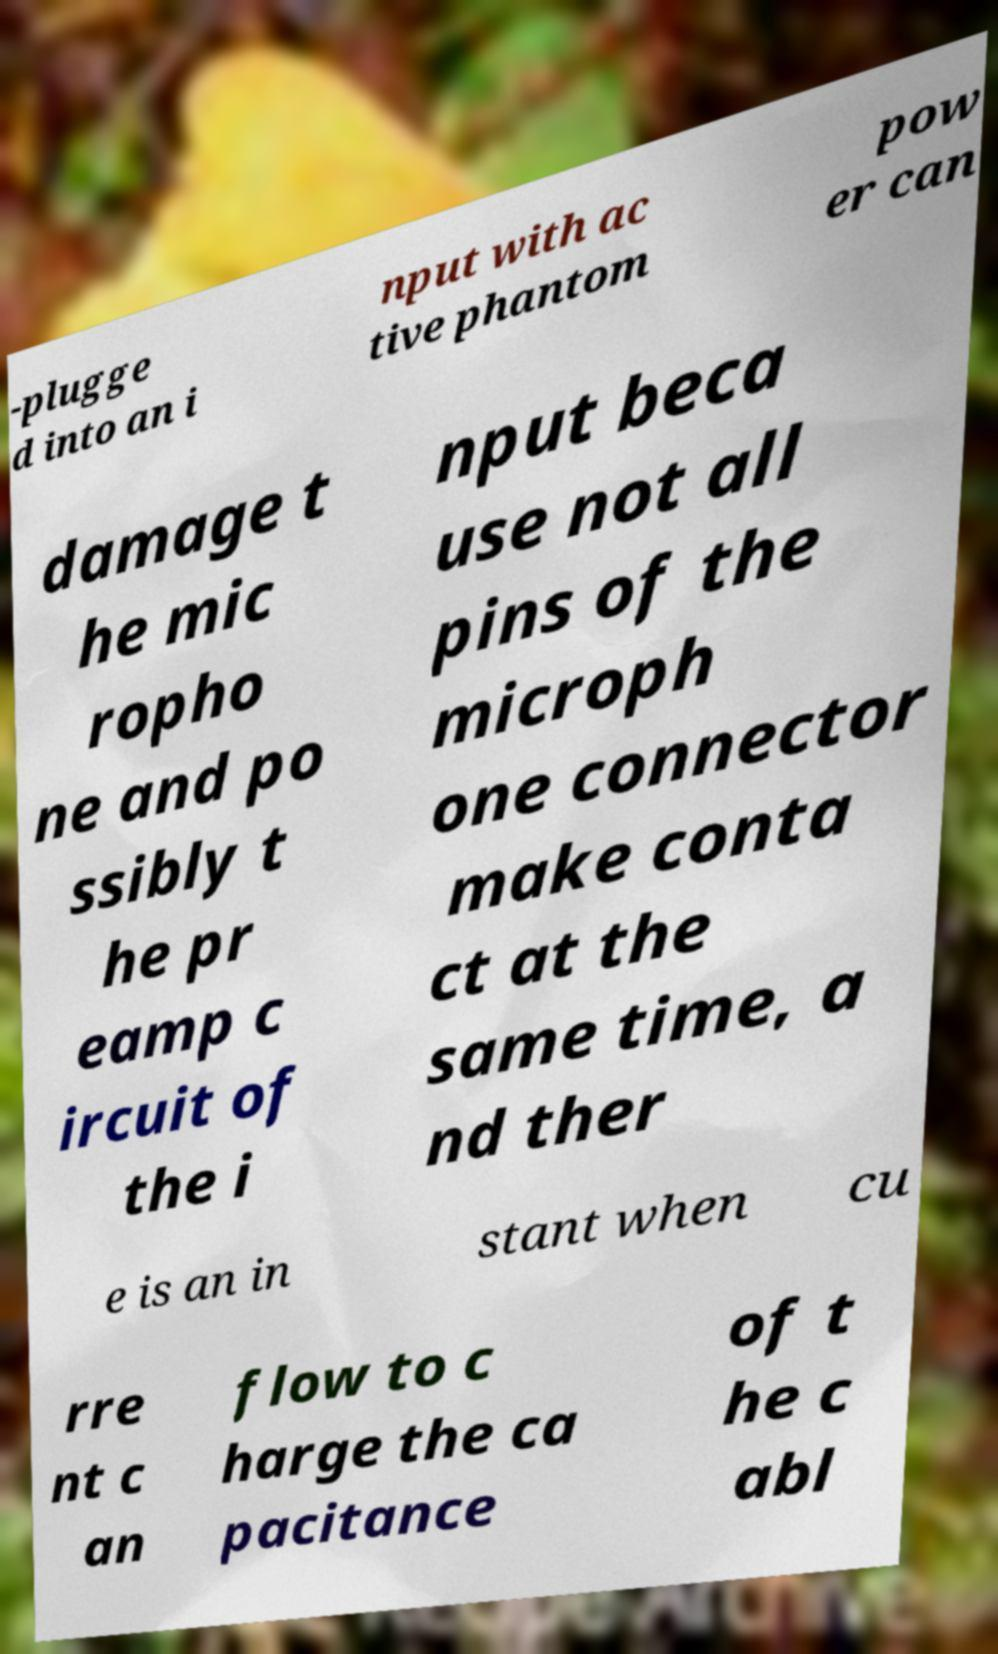For documentation purposes, I need the text within this image transcribed. Could you provide that? -plugge d into an i nput with ac tive phantom pow er can damage t he mic ropho ne and po ssibly t he pr eamp c ircuit of the i nput beca use not all pins of the microph one connector make conta ct at the same time, a nd ther e is an in stant when cu rre nt c an flow to c harge the ca pacitance of t he c abl 